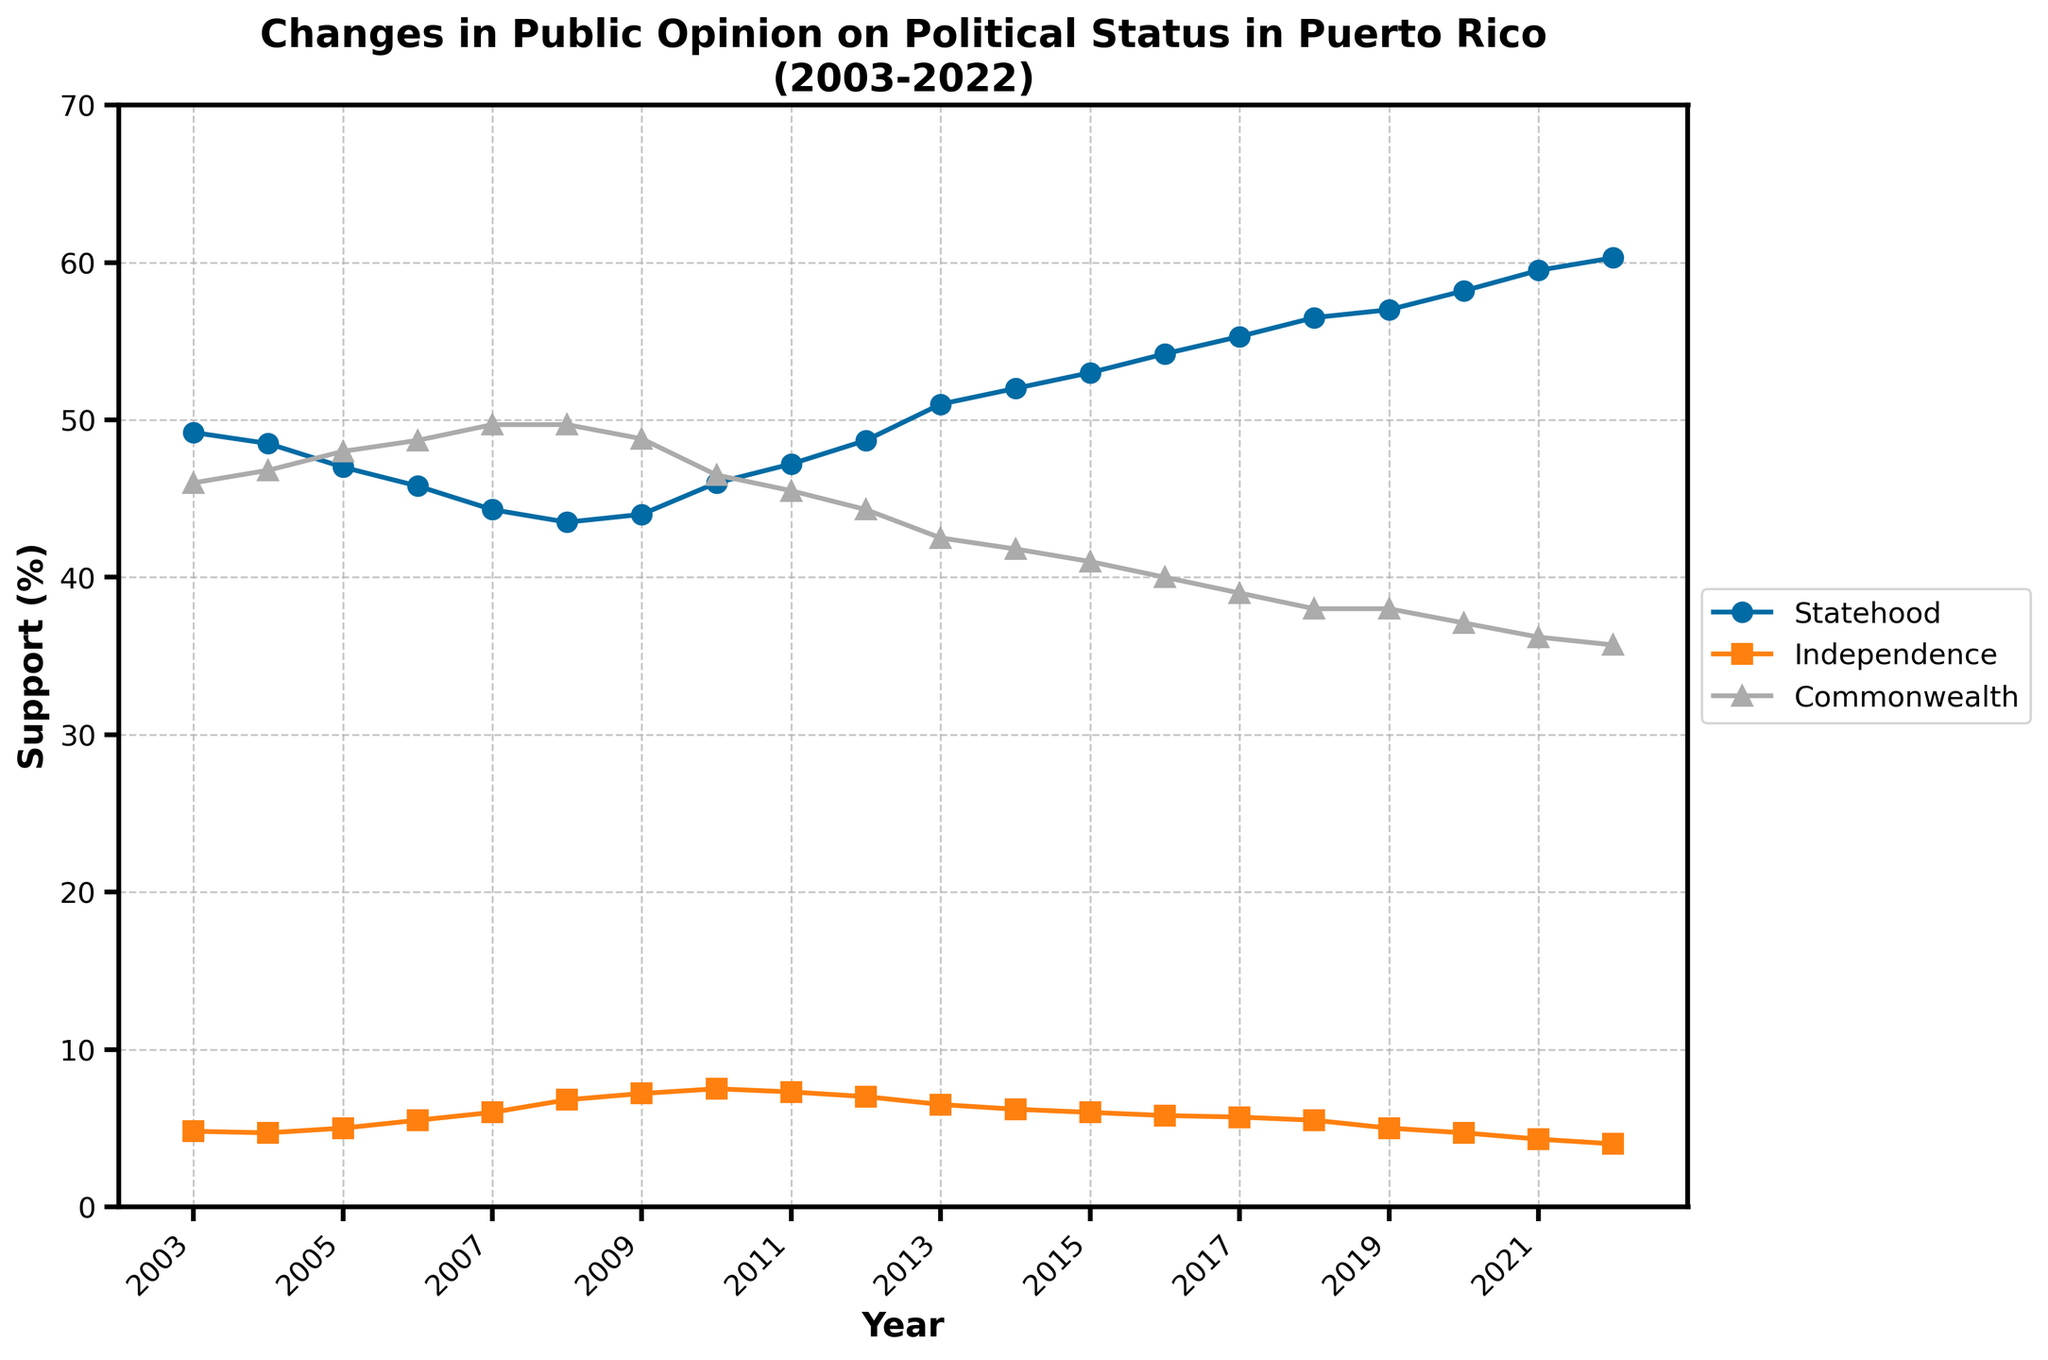What is the title of the figure? The title of the figure is displayed prominently at the top and usually describes the content. Here, it indicates the figure is about changes in public opinion on political status in Puerto Rico over a specific timeframe.
Answer: Changes in Public Opinion on Political Status in Puerto Rico (2003-2022) How many data points are plotted for each political option (Statehood, Independence, Commonwealth)? Count the number of markers for each line on the plot. Each marker represents a data point for the respective political option over the years.
Answer: 20 In what year does Statehood support begin to exceed 50%? Look at the Statehood support line and identify the first year in which the value crosses the 50% threshold.
Answer: 2013 What is the difference in support for Independence between 2003 and 2022? Subtract the Independence support percentage in 2003 from the percentage in 2022.
Answer: -0.8% Which political option had the highest support in 2006? Compare the values of Statehood Support, Independence Support, and Commonwealth Support in 2006. The option with the largest value is the answer.
Answer: Commonwealth Which year had the highest support for Statehood, and what was the percentage? Locate the peak point of the Statehood support line and note the corresponding year and percentage.
Answer: 2022, 60.3% How did the support for Commonwealth change from 2003 to 2022? Compare the percentage of Commonwealth Support in 2003 with that in 2022 and describe the trend (increasing or decreasing).
Answer: Decreased What is the average support for Independence over the 20-year span? Sum the percentages for Independence Support for each year from 2003 to 2022, then divide by the number of years (20).
Answer: 5.58% How did public opinion on Statehood change from 2003 to 2022? Compare the percentage of Statehood Support in 2003 with that in 2022 and describe the trend (increasing or decreasing).
Answer: Increased Which political option shows a generally decreasing trend over the years? By examining the overall trend lines for each political option, identify the one that shows a consistent decrease.
Answer: Commonwealth 